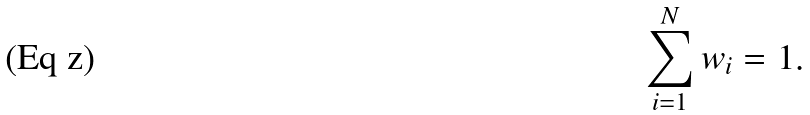Convert formula to latex. <formula><loc_0><loc_0><loc_500><loc_500>\sum _ { i = 1 } ^ { N } w _ { i } = 1 .</formula> 